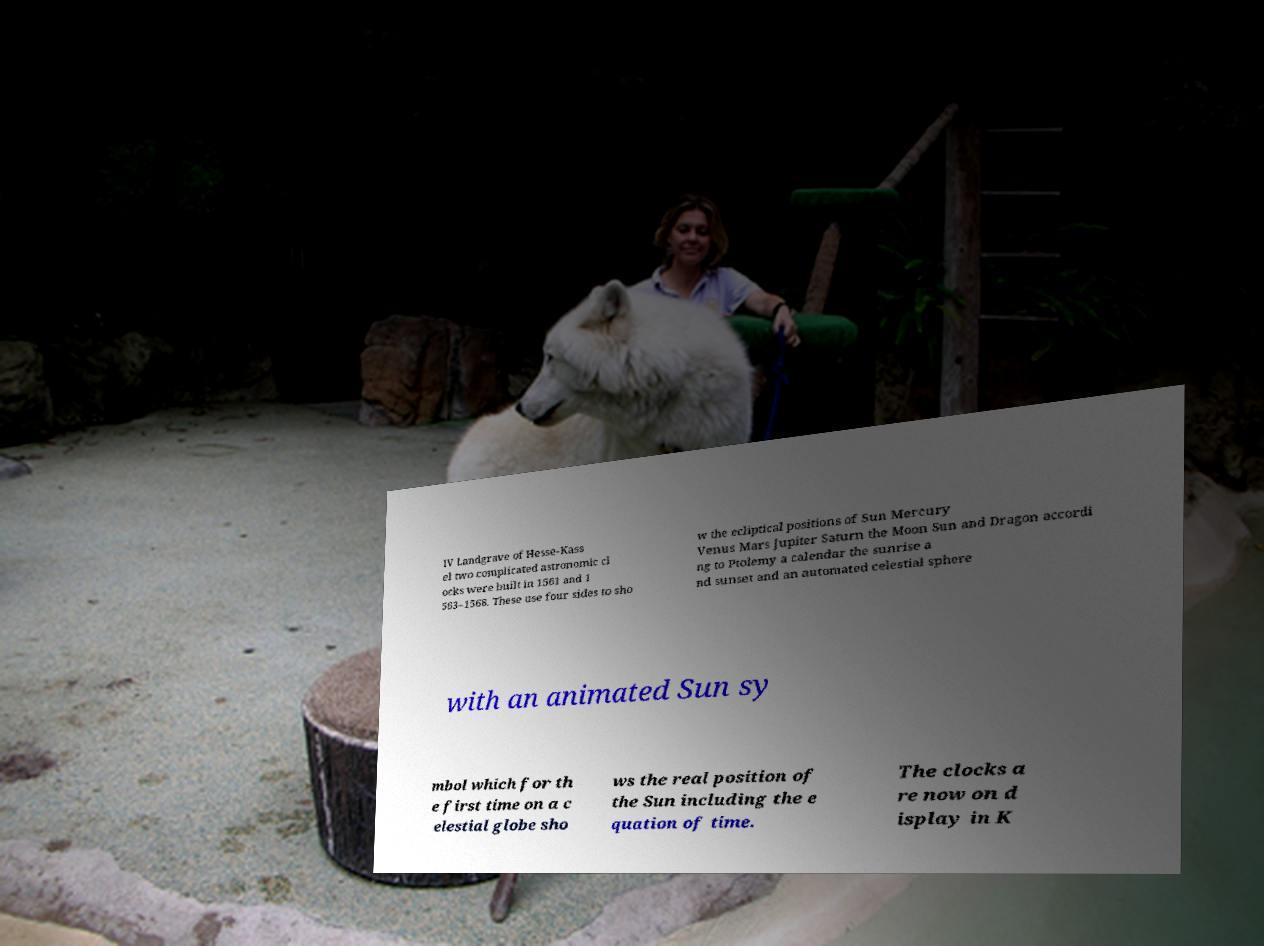Please read and relay the text visible in this image. What does it say? IV Landgrave of Hesse-Kass el two complicated astronomic cl ocks were built in 1561 and 1 563–1568. These use four sides to sho w the ecliptical positions of Sun Mercury Venus Mars Jupiter Saturn the Moon Sun and Dragon accordi ng to Ptolemy a calendar the sunrise a nd sunset and an automated celestial sphere with an animated Sun sy mbol which for th e first time on a c elestial globe sho ws the real position of the Sun including the e quation of time. The clocks a re now on d isplay in K 